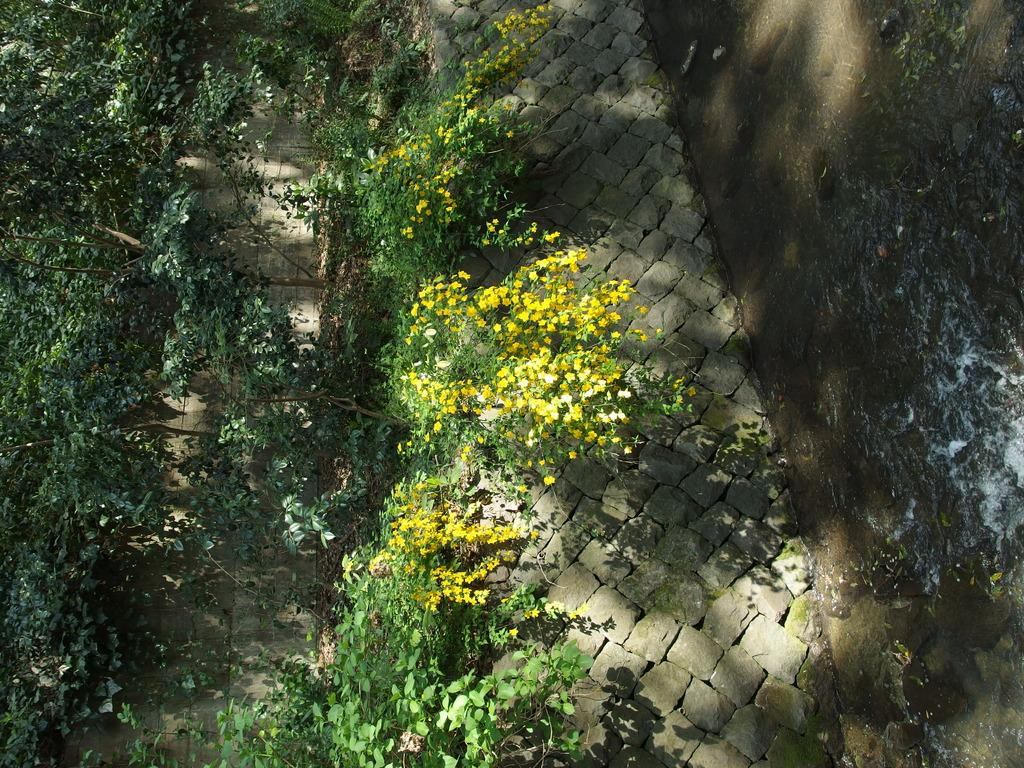What can be seen on the right side of the image? There is water on the right side of the image. What feature is present in the middle of the image? There is a path in the image. What type of vegetation is on the left side of the image? There are yellow flowers and green plants on the left side of the image. How many apples are hanging from the yoke in the image? There is no yoke or apple present in the image. Is there a beggar visible in the image? There is no beggar present in the image. 